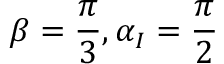<formula> <loc_0><loc_0><loc_500><loc_500>\beta = \frac { \pi } { 3 } , \alpha _ { I } = \frac { \pi } { 2 }</formula> 